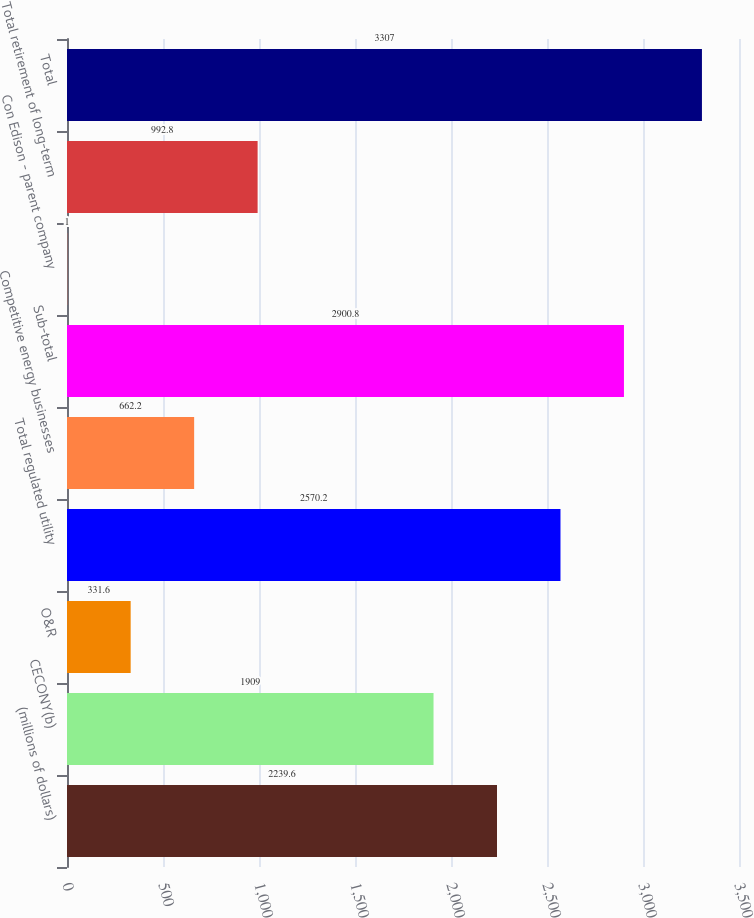Convert chart to OTSL. <chart><loc_0><loc_0><loc_500><loc_500><bar_chart><fcel>(millions of dollars)<fcel>CECONY(b)<fcel>O&R<fcel>Total regulated utility<fcel>Competitive energy businesses<fcel>Sub-total<fcel>Con Edison - parent company<fcel>Total retirement of long-term<fcel>Total<nl><fcel>2239.6<fcel>1909<fcel>331.6<fcel>2570.2<fcel>662.2<fcel>2900.8<fcel>1<fcel>992.8<fcel>3307<nl></chart> 